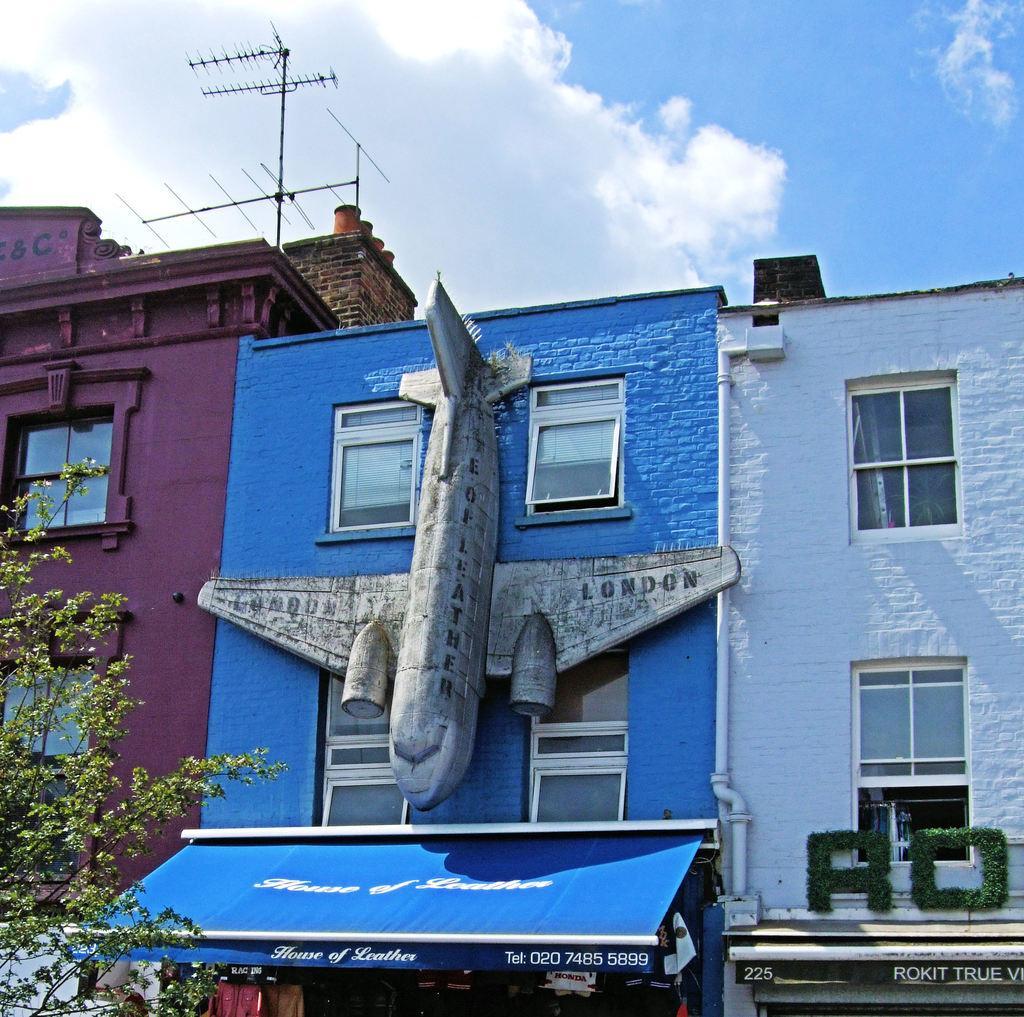How would you summarize this image in a sentence or two? In this image there are three buildings. On the blue color building there is an airplane shape object. There is a tree on the left side. There are clouds in the sky. 